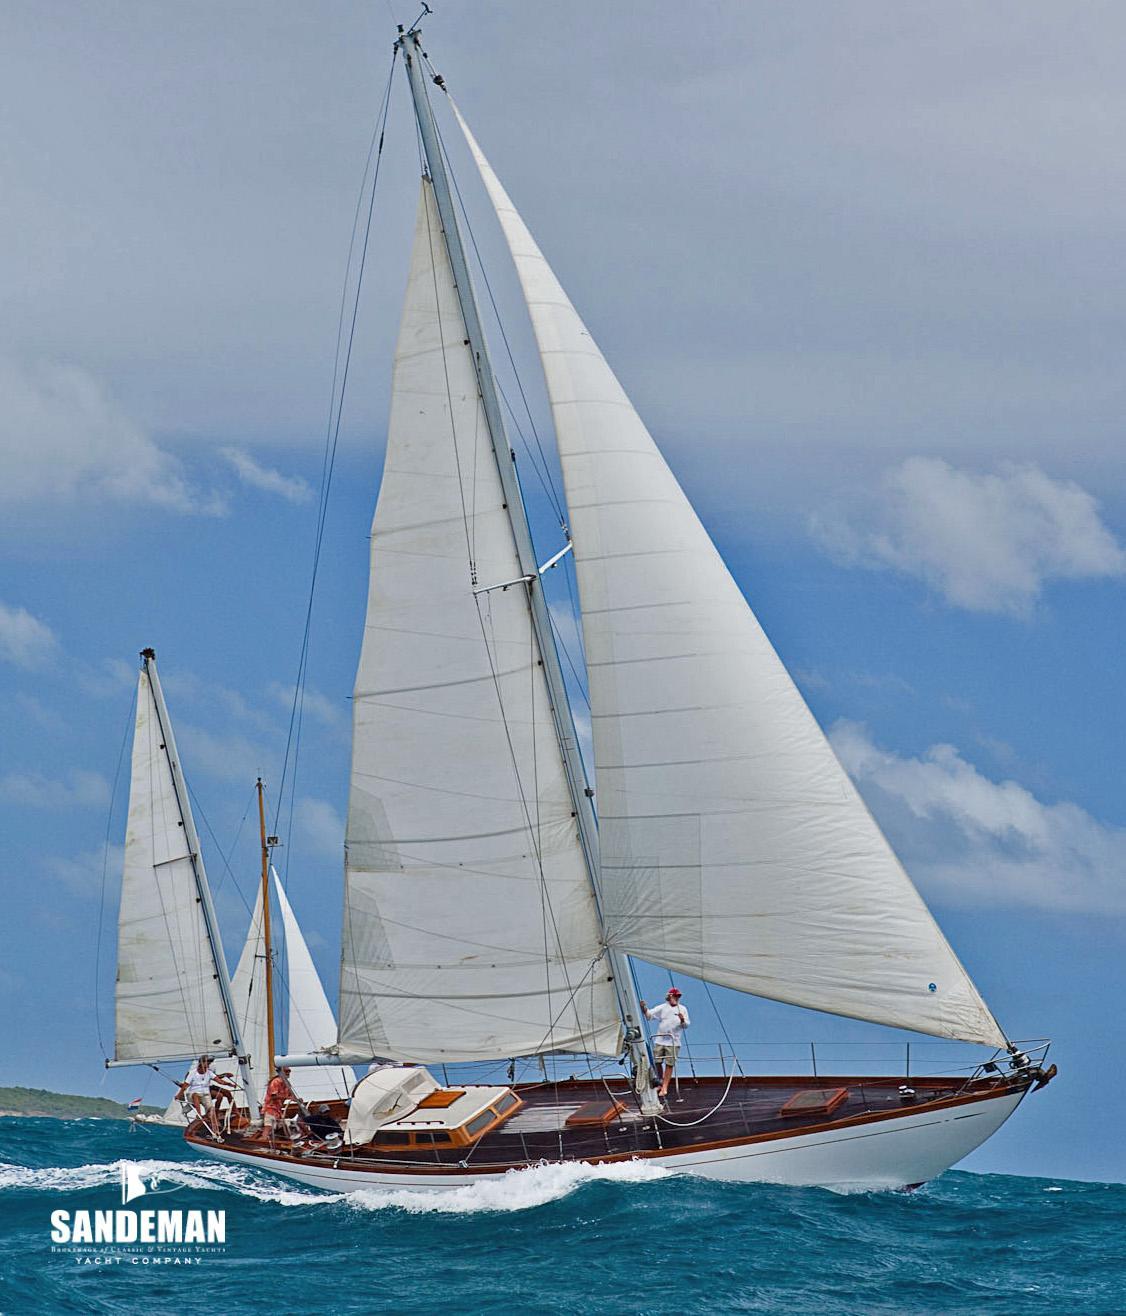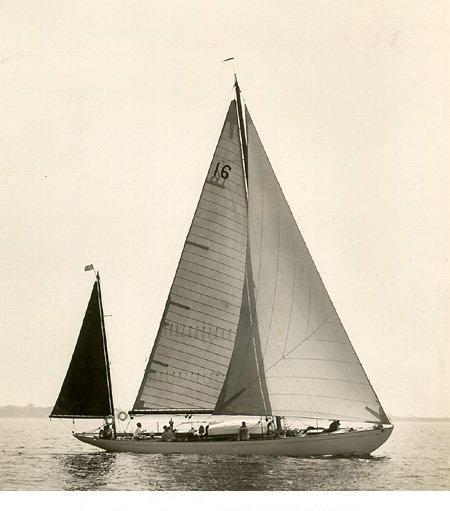The first image is the image on the left, the second image is the image on the right. For the images shown, is this caption "The left and right image contains the same number sailboats with open sails." true? Answer yes or no. Yes. The first image is the image on the left, the second image is the image on the right. Considering the images on both sides, is "Two boats are sailing." valid? Answer yes or no. Yes. 